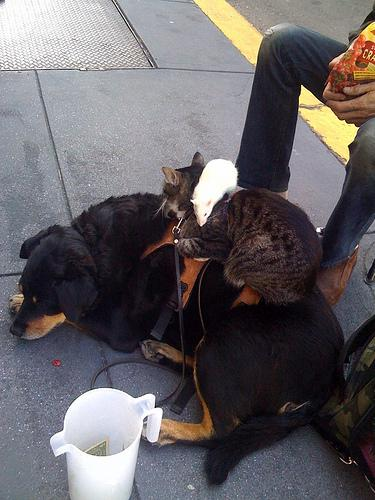Which mammal will disturb more species with it's movement?

Choices:
A) cat
B) rat
C) man
D) dog dog 